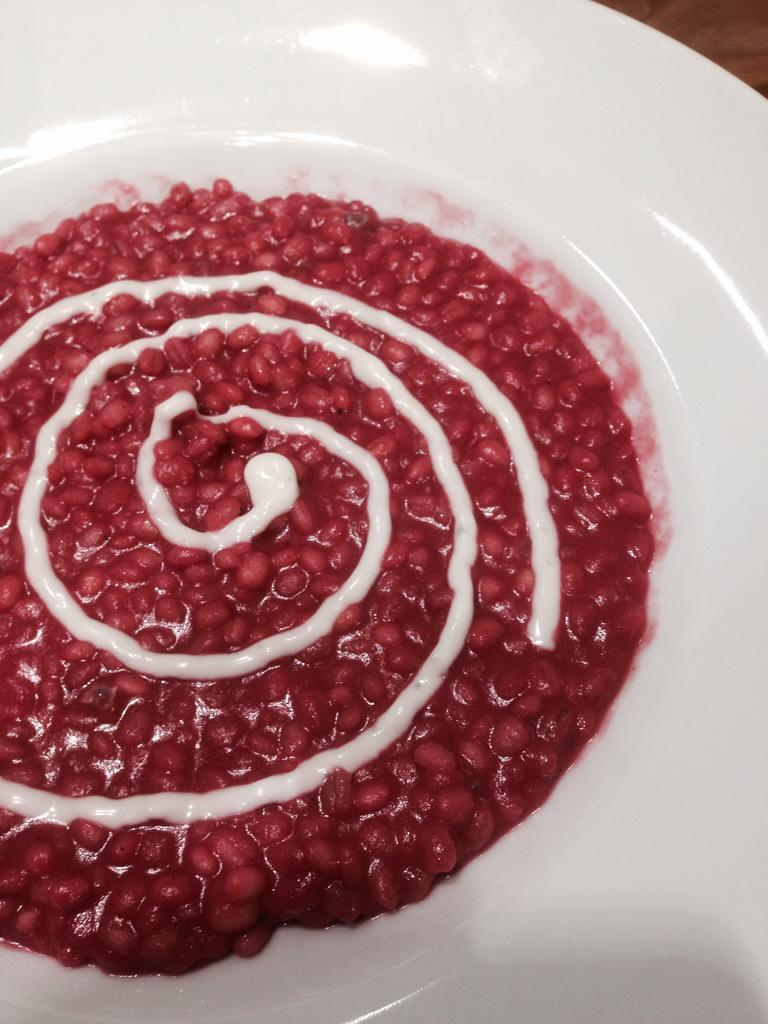What is the main object in the image? There is a white color palette in the image. What is on the palette? The palette contains food items. What can be seen in the background of the image? There is an object in the background that seems to be a table. Can you see any fights or guns in the image? No, there are no fights or guns present in the image. 